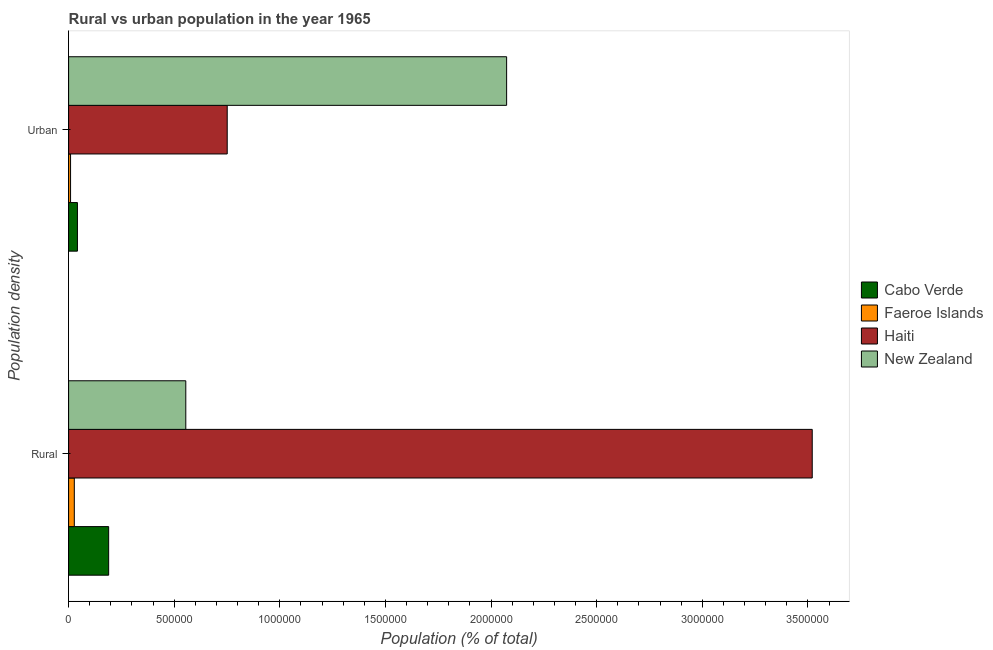How many different coloured bars are there?
Your answer should be very brief. 4. How many groups of bars are there?
Your answer should be compact. 2. How many bars are there on the 1st tick from the top?
Ensure brevity in your answer.  4. How many bars are there on the 1st tick from the bottom?
Your response must be concise. 4. What is the label of the 1st group of bars from the top?
Ensure brevity in your answer.  Urban. What is the rural population density in Cabo Verde?
Your answer should be compact. 1.90e+05. Across all countries, what is the maximum urban population density?
Make the answer very short. 2.07e+06. Across all countries, what is the minimum rural population density?
Ensure brevity in your answer.  2.71e+04. In which country was the rural population density maximum?
Your answer should be compact. Haiti. In which country was the rural population density minimum?
Keep it short and to the point. Faeroe Islands. What is the total urban population density in the graph?
Keep it short and to the point. 2.88e+06. What is the difference between the rural population density in Cabo Verde and that in Faeroe Islands?
Provide a succinct answer. 1.63e+05. What is the difference between the rural population density in Cabo Verde and the urban population density in New Zealand?
Your answer should be compact. -1.88e+06. What is the average rural population density per country?
Give a very brief answer. 1.07e+06. What is the difference between the urban population density and rural population density in New Zealand?
Keep it short and to the point. 1.52e+06. In how many countries, is the rural population density greater than 2600000 %?
Provide a short and direct response. 1. What is the ratio of the urban population density in New Zealand to that in Cabo Verde?
Offer a very short reply. 49.58. Is the urban population density in New Zealand less than that in Faeroe Islands?
Offer a very short reply. No. In how many countries, is the rural population density greater than the average rural population density taken over all countries?
Offer a very short reply. 1. What does the 2nd bar from the top in Rural represents?
Offer a terse response. Haiti. What does the 2nd bar from the bottom in Urban represents?
Provide a succinct answer. Faeroe Islands. How many bars are there?
Offer a terse response. 8. How many countries are there in the graph?
Provide a succinct answer. 4. Are the values on the major ticks of X-axis written in scientific E-notation?
Offer a terse response. No. Does the graph contain any zero values?
Your response must be concise. No. How many legend labels are there?
Offer a terse response. 4. How are the legend labels stacked?
Your answer should be very brief. Vertical. What is the title of the graph?
Ensure brevity in your answer.  Rural vs urban population in the year 1965. Does "St. Lucia" appear as one of the legend labels in the graph?
Offer a very short reply. No. What is the label or title of the X-axis?
Ensure brevity in your answer.  Population (% of total). What is the label or title of the Y-axis?
Your answer should be compact. Population density. What is the Population (% of total) of Cabo Verde in Rural?
Your answer should be compact. 1.90e+05. What is the Population (% of total) of Faeroe Islands in Rural?
Your response must be concise. 2.71e+04. What is the Population (% of total) of Haiti in Rural?
Provide a short and direct response. 3.52e+06. What is the Population (% of total) in New Zealand in Rural?
Provide a short and direct response. 5.55e+05. What is the Population (% of total) of Cabo Verde in Urban?
Give a very brief answer. 4.18e+04. What is the Population (% of total) in Faeroe Islands in Urban?
Offer a terse response. 9292. What is the Population (% of total) of Haiti in Urban?
Your answer should be compact. 7.51e+05. What is the Population (% of total) in New Zealand in Urban?
Give a very brief answer. 2.07e+06. Across all Population density, what is the maximum Population (% of total) in Cabo Verde?
Your answer should be compact. 1.90e+05. Across all Population density, what is the maximum Population (% of total) of Faeroe Islands?
Your response must be concise. 2.71e+04. Across all Population density, what is the maximum Population (% of total) of Haiti?
Your response must be concise. 3.52e+06. Across all Population density, what is the maximum Population (% of total) of New Zealand?
Keep it short and to the point. 2.07e+06. Across all Population density, what is the minimum Population (% of total) in Cabo Verde?
Your answer should be very brief. 4.18e+04. Across all Population density, what is the minimum Population (% of total) in Faeroe Islands?
Give a very brief answer. 9292. Across all Population density, what is the minimum Population (% of total) in Haiti?
Your answer should be compact. 7.51e+05. Across all Population density, what is the minimum Population (% of total) of New Zealand?
Provide a short and direct response. 5.55e+05. What is the total Population (% of total) in Cabo Verde in the graph?
Make the answer very short. 2.31e+05. What is the total Population (% of total) of Faeroe Islands in the graph?
Your answer should be very brief. 3.64e+04. What is the total Population (% of total) of Haiti in the graph?
Offer a terse response. 4.27e+06. What is the total Population (% of total) of New Zealand in the graph?
Ensure brevity in your answer.  2.63e+06. What is the difference between the Population (% of total) in Cabo Verde in Rural and that in Urban?
Your answer should be very brief. 1.48e+05. What is the difference between the Population (% of total) of Faeroe Islands in Rural and that in Urban?
Keep it short and to the point. 1.78e+04. What is the difference between the Population (% of total) in Haiti in Rural and that in Urban?
Your answer should be very brief. 2.77e+06. What is the difference between the Population (% of total) in New Zealand in Rural and that in Urban?
Offer a terse response. -1.52e+06. What is the difference between the Population (% of total) in Cabo Verde in Rural and the Population (% of total) in Faeroe Islands in Urban?
Your response must be concise. 1.80e+05. What is the difference between the Population (% of total) in Cabo Verde in Rural and the Population (% of total) in Haiti in Urban?
Provide a short and direct response. -5.61e+05. What is the difference between the Population (% of total) of Cabo Verde in Rural and the Population (% of total) of New Zealand in Urban?
Offer a very short reply. -1.88e+06. What is the difference between the Population (% of total) in Faeroe Islands in Rural and the Population (% of total) in Haiti in Urban?
Provide a short and direct response. -7.24e+05. What is the difference between the Population (% of total) of Faeroe Islands in Rural and the Population (% of total) of New Zealand in Urban?
Give a very brief answer. -2.05e+06. What is the difference between the Population (% of total) of Haiti in Rural and the Population (% of total) of New Zealand in Urban?
Provide a succinct answer. 1.45e+06. What is the average Population (% of total) of Cabo Verde per Population density?
Offer a terse response. 1.16e+05. What is the average Population (% of total) in Faeroe Islands per Population density?
Make the answer very short. 1.82e+04. What is the average Population (% of total) of Haiti per Population density?
Give a very brief answer. 2.14e+06. What is the average Population (% of total) in New Zealand per Population density?
Your response must be concise. 1.31e+06. What is the difference between the Population (% of total) of Cabo Verde and Population (% of total) of Faeroe Islands in Rural?
Your answer should be compact. 1.63e+05. What is the difference between the Population (% of total) in Cabo Verde and Population (% of total) in Haiti in Rural?
Your response must be concise. -3.33e+06. What is the difference between the Population (% of total) of Cabo Verde and Population (% of total) of New Zealand in Rural?
Provide a succinct answer. -3.65e+05. What is the difference between the Population (% of total) in Faeroe Islands and Population (% of total) in Haiti in Rural?
Your response must be concise. -3.49e+06. What is the difference between the Population (% of total) in Faeroe Islands and Population (% of total) in New Zealand in Rural?
Offer a terse response. -5.28e+05. What is the difference between the Population (% of total) in Haiti and Population (% of total) in New Zealand in Rural?
Keep it short and to the point. 2.97e+06. What is the difference between the Population (% of total) in Cabo Verde and Population (% of total) in Faeroe Islands in Urban?
Make the answer very short. 3.25e+04. What is the difference between the Population (% of total) in Cabo Verde and Population (% of total) in Haiti in Urban?
Give a very brief answer. -7.09e+05. What is the difference between the Population (% of total) of Cabo Verde and Population (% of total) of New Zealand in Urban?
Your answer should be compact. -2.03e+06. What is the difference between the Population (% of total) of Faeroe Islands and Population (% of total) of Haiti in Urban?
Provide a succinct answer. -7.42e+05. What is the difference between the Population (% of total) in Faeroe Islands and Population (% of total) in New Zealand in Urban?
Keep it short and to the point. -2.06e+06. What is the difference between the Population (% of total) of Haiti and Population (% of total) of New Zealand in Urban?
Your response must be concise. -1.32e+06. What is the ratio of the Population (% of total) of Cabo Verde in Rural to that in Urban?
Your answer should be compact. 4.53. What is the ratio of the Population (% of total) in Faeroe Islands in Rural to that in Urban?
Offer a very short reply. 2.91. What is the ratio of the Population (% of total) in Haiti in Rural to that in Urban?
Offer a terse response. 4.69. What is the ratio of the Population (% of total) in New Zealand in Rural to that in Urban?
Ensure brevity in your answer.  0.27. What is the difference between the highest and the second highest Population (% of total) in Cabo Verde?
Offer a terse response. 1.48e+05. What is the difference between the highest and the second highest Population (% of total) in Faeroe Islands?
Your response must be concise. 1.78e+04. What is the difference between the highest and the second highest Population (% of total) in Haiti?
Provide a succinct answer. 2.77e+06. What is the difference between the highest and the second highest Population (% of total) of New Zealand?
Make the answer very short. 1.52e+06. What is the difference between the highest and the lowest Population (% of total) of Cabo Verde?
Give a very brief answer. 1.48e+05. What is the difference between the highest and the lowest Population (% of total) of Faeroe Islands?
Your answer should be very brief. 1.78e+04. What is the difference between the highest and the lowest Population (% of total) of Haiti?
Offer a very short reply. 2.77e+06. What is the difference between the highest and the lowest Population (% of total) of New Zealand?
Your response must be concise. 1.52e+06. 